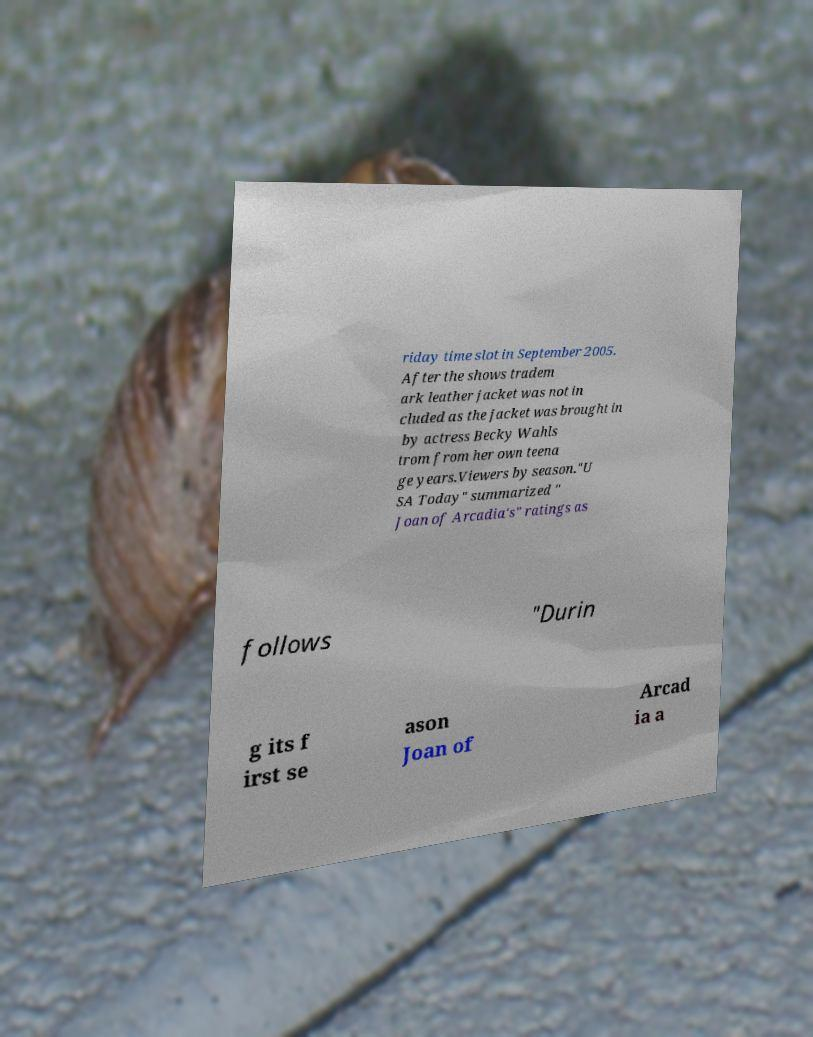Please identify and transcribe the text found in this image. riday time slot in September 2005. After the shows tradem ark leather jacket was not in cluded as the jacket was brought in by actress Becky Wahls trom from her own teena ge years.Viewers by season."U SA Today" summarized " Joan of Arcadia's" ratings as follows "Durin g its f irst se ason Joan of Arcad ia a 